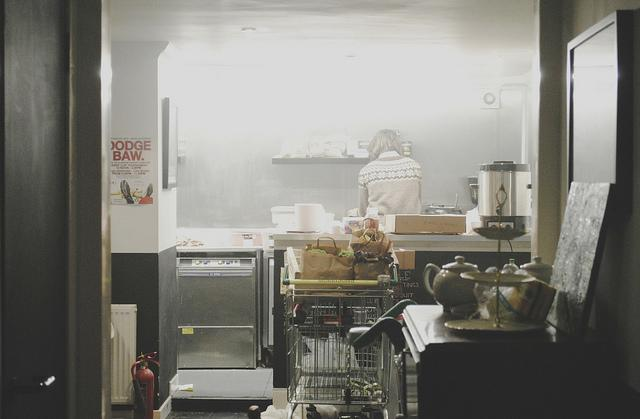What is the woman doing? Please explain your reasoning. working. This setting appears to be a kitchen of some sorts.  her position indicates that she is preparing some sort of food.  most restaurants only allow employees to prepare meals so she is most likely employed. 